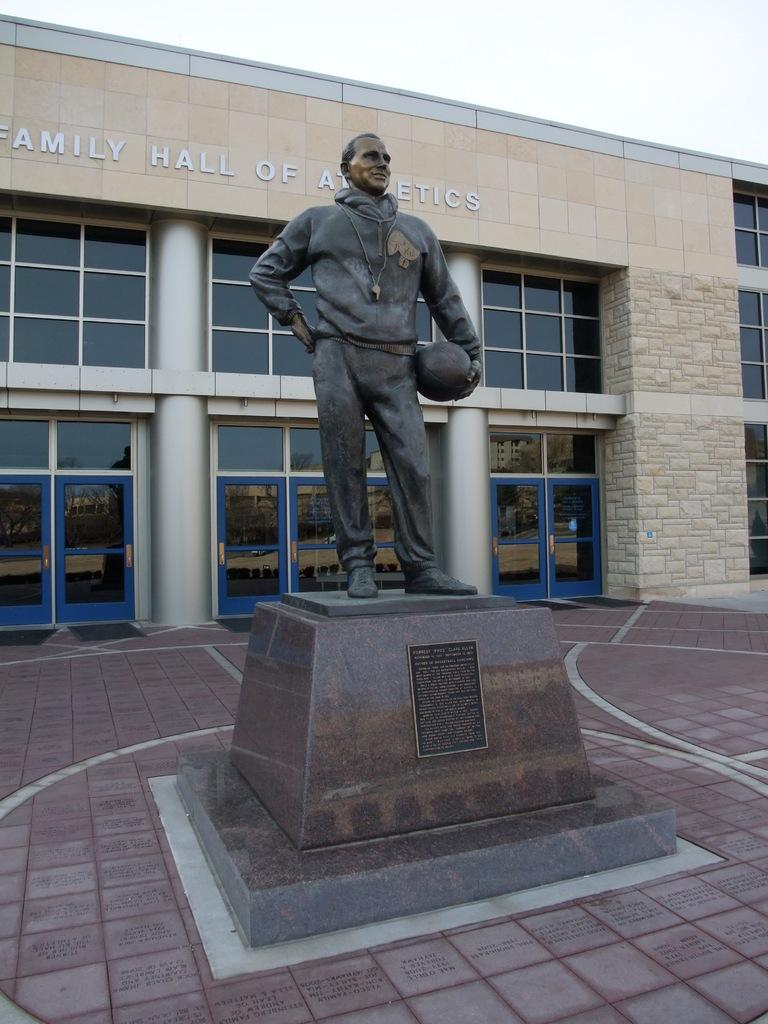What is the main subject of the image? There is a statue of a person in the image. What is the person in the statue holding? The person is holding a ball in their hand. What can be seen in the background of the image? There is a building visible in the background of the image. What is the spark range of the person in the image? There is no mention of a spark or range in the image, as it features a statue of a person holding a ball. 